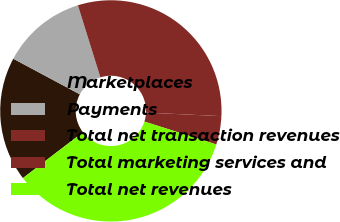<chart> <loc_0><loc_0><loc_500><loc_500><pie_chart><fcel>Marketplaces<fcel>Payments<fcel>Total net transaction revenues<fcel>Total marketing services and<fcel>Total net revenues<nl><fcel>18.2%<fcel>12.37%<fcel>30.57%<fcel>4.15%<fcel>34.72%<nl></chart> 